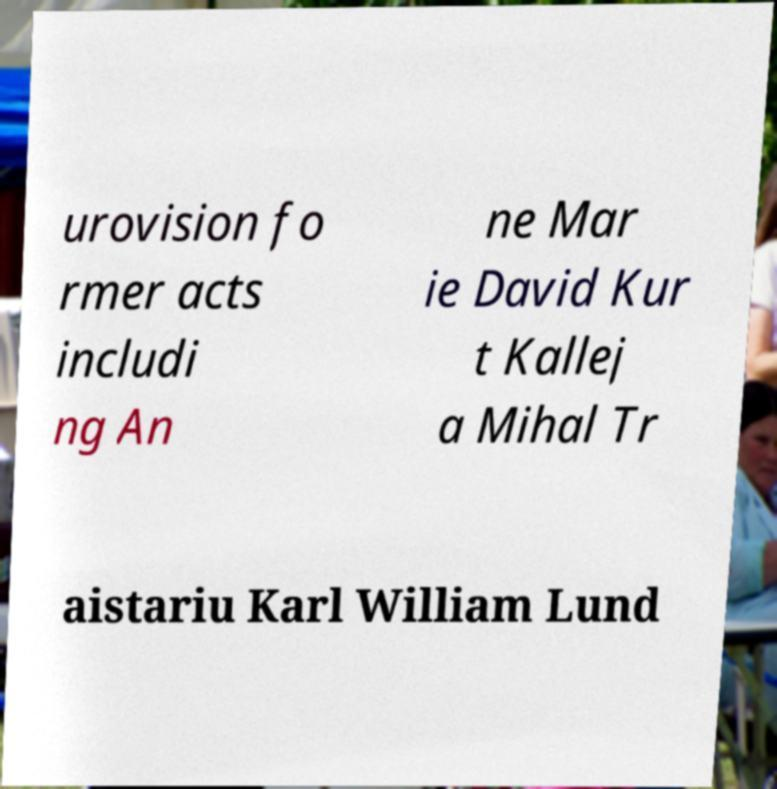I need the written content from this picture converted into text. Can you do that? urovision fo rmer acts includi ng An ne Mar ie David Kur t Kallej a Mihal Tr aistariu Karl William Lund 